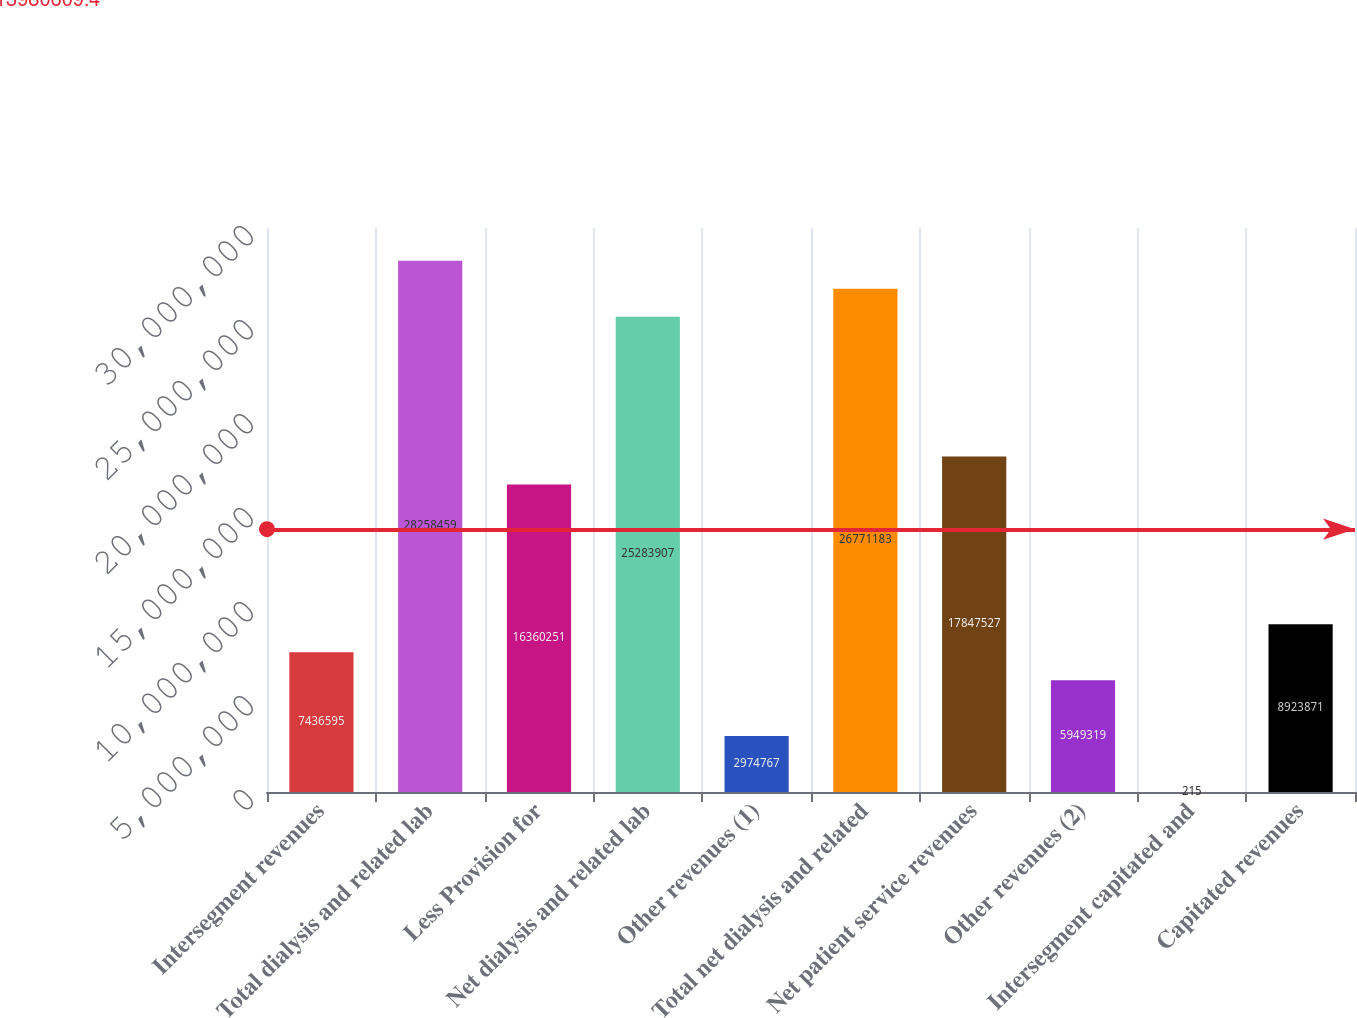Convert chart. <chart><loc_0><loc_0><loc_500><loc_500><bar_chart><fcel>Intersegment revenues<fcel>Total dialysis and related lab<fcel>Less Provision for<fcel>Net dialysis and related lab<fcel>Other revenues (1)<fcel>Total net dialysis and related<fcel>Net patient service revenues<fcel>Other revenues (2)<fcel>Intersegment capitated and<fcel>Capitated revenues<nl><fcel>7.4366e+06<fcel>2.82585e+07<fcel>1.63603e+07<fcel>2.52839e+07<fcel>2.97477e+06<fcel>2.67712e+07<fcel>1.78475e+07<fcel>5.94932e+06<fcel>215<fcel>8.92387e+06<nl></chart> 